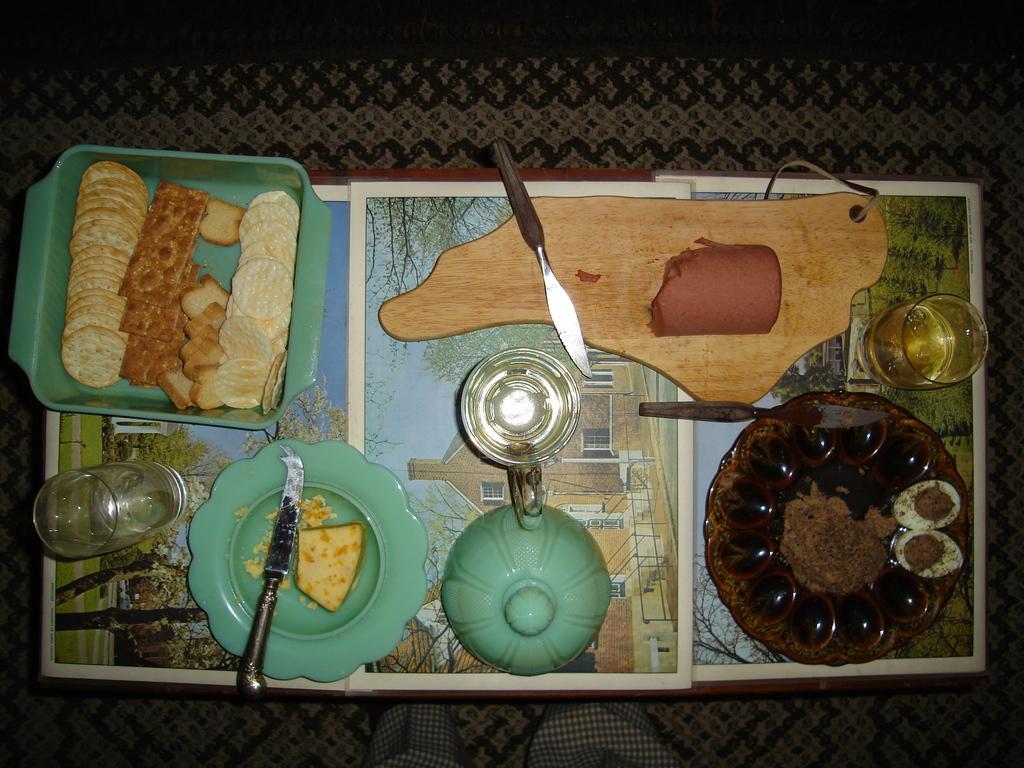Please provide a concise description of this image. In this picture there is food and there are knives on the plates and there is food in the bowl. There are plates, bowls, glasses and there is a chopping board on the table and there are pictures of buildings and trees on the table. At the bottom there is a mat and there is a person standing in front of the table. 